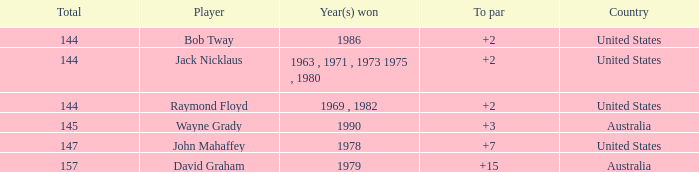What was the average round score of the player who won in 1978? 147.0. 